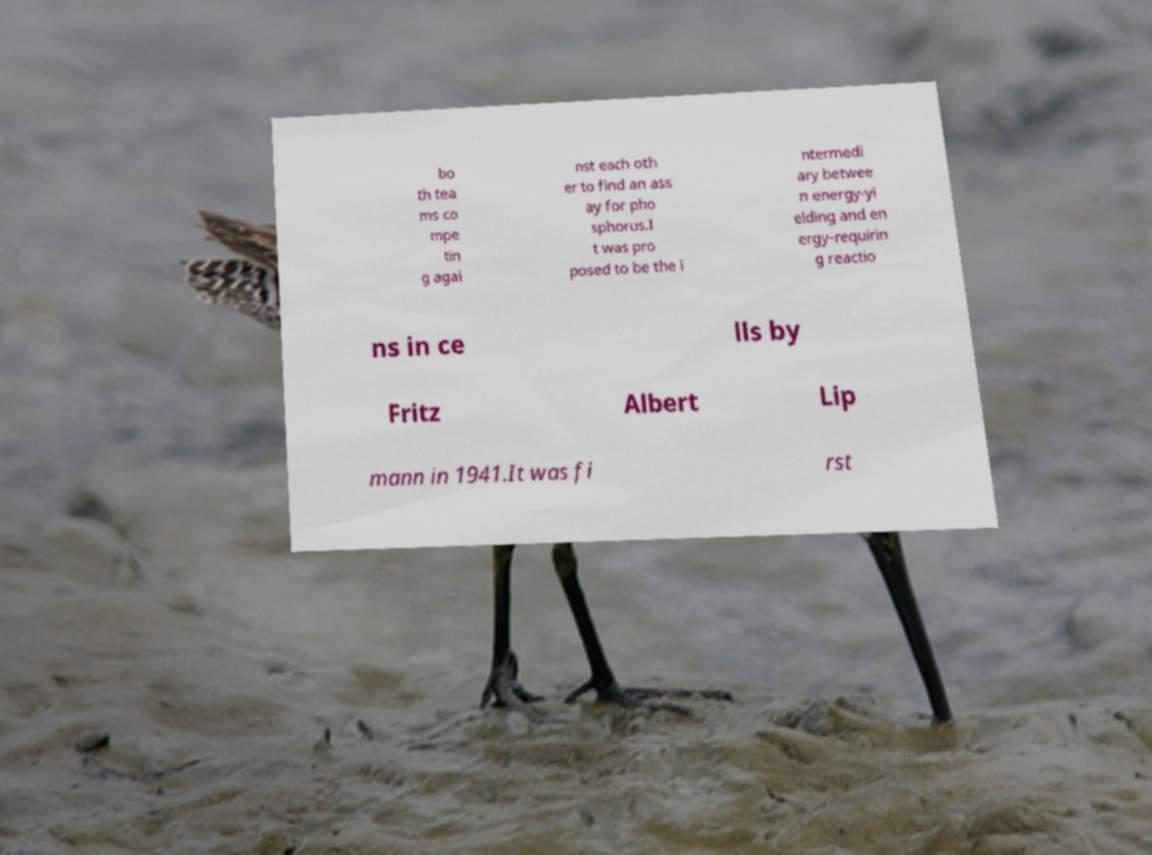Can you accurately transcribe the text from the provided image for me? bo th tea ms co mpe tin g agai nst each oth er to find an ass ay for pho sphorus.I t was pro posed to be the i ntermedi ary betwee n energy-yi elding and en ergy-requirin g reactio ns in ce lls by Fritz Albert Lip mann in 1941.It was fi rst 